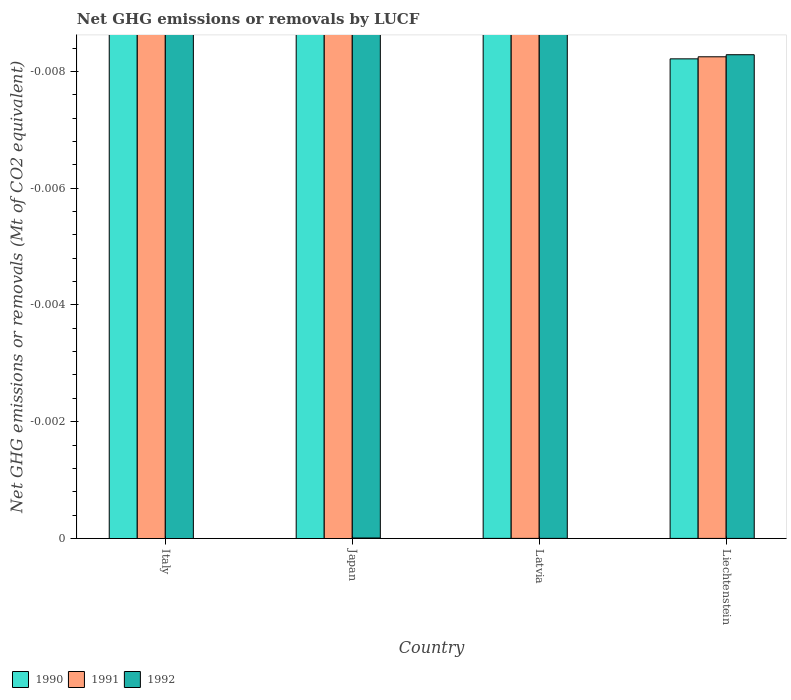Are the number of bars per tick equal to the number of legend labels?
Offer a very short reply. No. How many bars are there on the 4th tick from the left?
Provide a succinct answer. 0. What is the label of the 2nd group of bars from the left?
Provide a short and direct response. Japan. What is the net GHG emissions or removals by LUCF in 1991 in Japan?
Your answer should be compact. 0. What is the total net GHG emissions or removals by LUCF in 1992 in the graph?
Make the answer very short. 0. What is the difference between the net GHG emissions or removals by LUCF in 1990 in Italy and the net GHG emissions or removals by LUCF in 1991 in Latvia?
Provide a short and direct response. 0. In how many countries, is the net GHG emissions or removals by LUCF in 1991 greater than the average net GHG emissions or removals by LUCF in 1991 taken over all countries?
Provide a short and direct response. 0. Is it the case that in every country, the sum of the net GHG emissions or removals by LUCF in 1991 and net GHG emissions or removals by LUCF in 1990 is greater than the net GHG emissions or removals by LUCF in 1992?
Keep it short and to the point. No. Are all the bars in the graph horizontal?
Provide a succinct answer. No. How many countries are there in the graph?
Offer a very short reply. 4. What is the difference between two consecutive major ticks on the Y-axis?
Provide a short and direct response. 0. Does the graph contain any zero values?
Offer a very short reply. Yes. Does the graph contain grids?
Offer a terse response. No. Where does the legend appear in the graph?
Offer a very short reply. Bottom left. How are the legend labels stacked?
Ensure brevity in your answer.  Horizontal. What is the title of the graph?
Your answer should be very brief. Net GHG emissions or removals by LUCF. What is the label or title of the X-axis?
Keep it short and to the point. Country. What is the label or title of the Y-axis?
Ensure brevity in your answer.  Net GHG emissions or removals (Mt of CO2 equivalent). What is the Net GHG emissions or removals (Mt of CO2 equivalent) in 1990 in Italy?
Ensure brevity in your answer.  0. What is the Net GHG emissions or removals (Mt of CO2 equivalent) of 1992 in Latvia?
Provide a succinct answer. 0. What is the Net GHG emissions or removals (Mt of CO2 equivalent) of 1990 in Liechtenstein?
Offer a terse response. 0. What is the total Net GHG emissions or removals (Mt of CO2 equivalent) in 1990 in the graph?
Offer a very short reply. 0. What is the total Net GHG emissions or removals (Mt of CO2 equivalent) of 1992 in the graph?
Make the answer very short. 0. What is the average Net GHG emissions or removals (Mt of CO2 equivalent) of 1990 per country?
Your response must be concise. 0. What is the average Net GHG emissions or removals (Mt of CO2 equivalent) in 1991 per country?
Your answer should be compact. 0. 